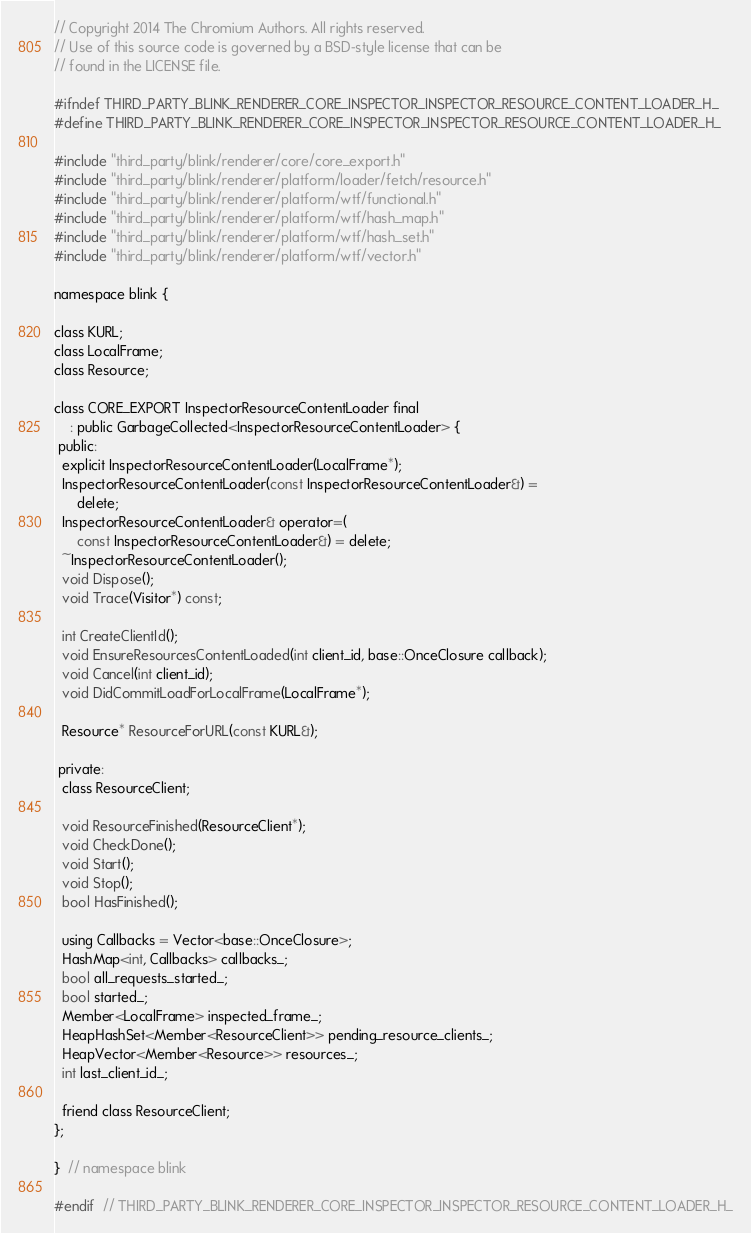Convert code to text. <code><loc_0><loc_0><loc_500><loc_500><_C_>// Copyright 2014 The Chromium Authors. All rights reserved.
// Use of this source code is governed by a BSD-style license that can be
// found in the LICENSE file.

#ifndef THIRD_PARTY_BLINK_RENDERER_CORE_INSPECTOR_INSPECTOR_RESOURCE_CONTENT_LOADER_H_
#define THIRD_PARTY_BLINK_RENDERER_CORE_INSPECTOR_INSPECTOR_RESOURCE_CONTENT_LOADER_H_

#include "third_party/blink/renderer/core/core_export.h"
#include "third_party/blink/renderer/platform/loader/fetch/resource.h"
#include "third_party/blink/renderer/platform/wtf/functional.h"
#include "third_party/blink/renderer/platform/wtf/hash_map.h"
#include "third_party/blink/renderer/platform/wtf/hash_set.h"
#include "third_party/blink/renderer/platform/wtf/vector.h"

namespace blink {

class KURL;
class LocalFrame;
class Resource;

class CORE_EXPORT InspectorResourceContentLoader final
    : public GarbageCollected<InspectorResourceContentLoader> {
 public:
  explicit InspectorResourceContentLoader(LocalFrame*);
  InspectorResourceContentLoader(const InspectorResourceContentLoader&) =
      delete;
  InspectorResourceContentLoader& operator=(
      const InspectorResourceContentLoader&) = delete;
  ~InspectorResourceContentLoader();
  void Dispose();
  void Trace(Visitor*) const;

  int CreateClientId();
  void EnsureResourcesContentLoaded(int client_id, base::OnceClosure callback);
  void Cancel(int client_id);
  void DidCommitLoadForLocalFrame(LocalFrame*);

  Resource* ResourceForURL(const KURL&);

 private:
  class ResourceClient;

  void ResourceFinished(ResourceClient*);
  void CheckDone();
  void Start();
  void Stop();
  bool HasFinished();

  using Callbacks = Vector<base::OnceClosure>;
  HashMap<int, Callbacks> callbacks_;
  bool all_requests_started_;
  bool started_;
  Member<LocalFrame> inspected_frame_;
  HeapHashSet<Member<ResourceClient>> pending_resource_clients_;
  HeapVector<Member<Resource>> resources_;
  int last_client_id_;

  friend class ResourceClient;
};

}  // namespace blink

#endif  // THIRD_PARTY_BLINK_RENDERER_CORE_INSPECTOR_INSPECTOR_RESOURCE_CONTENT_LOADER_H_
</code> 